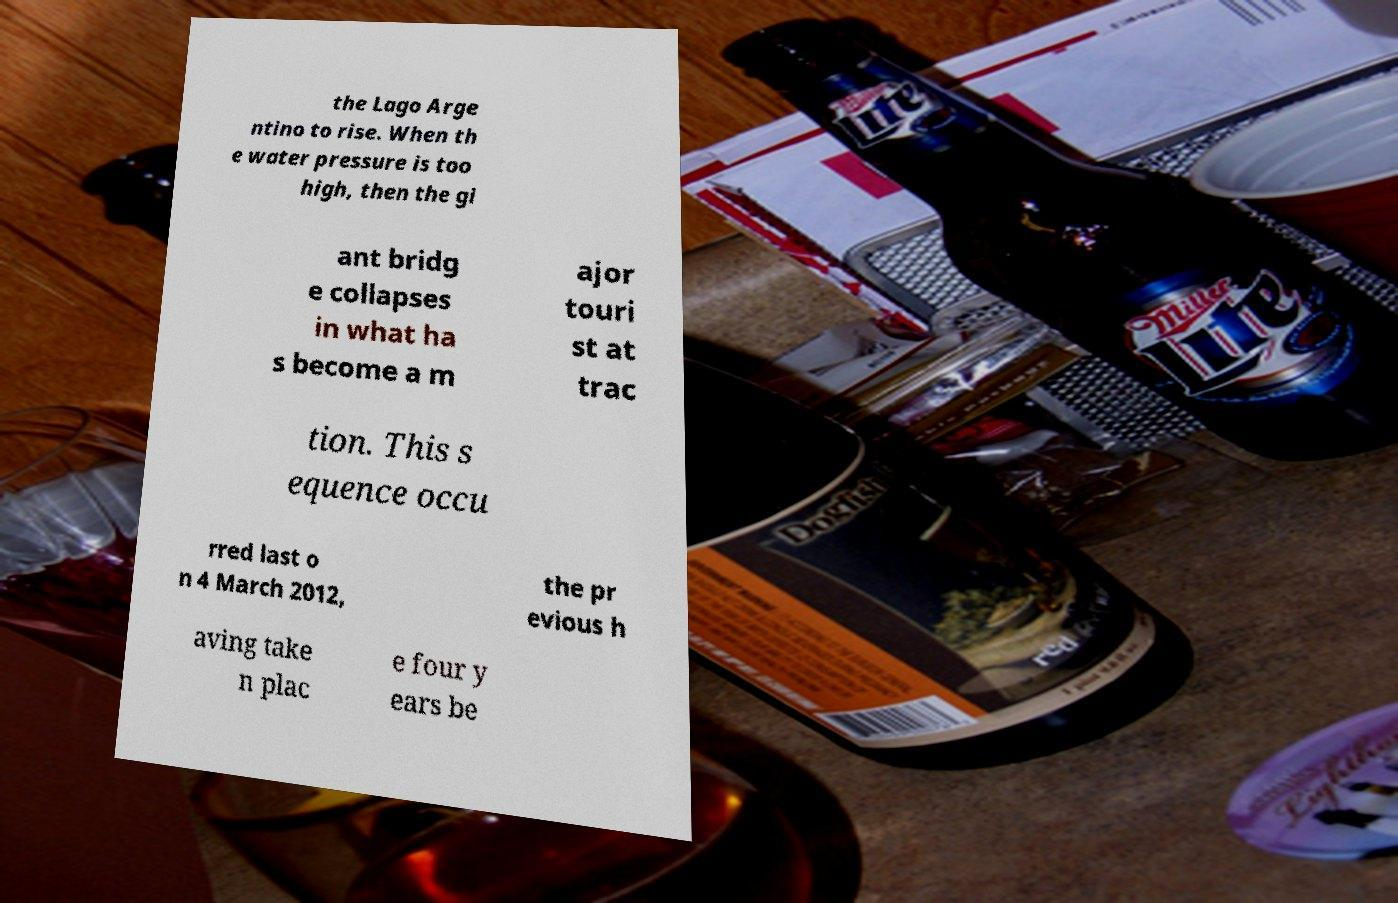Can you read and provide the text displayed in the image?This photo seems to have some interesting text. Can you extract and type it out for me? the Lago Arge ntino to rise. When th e water pressure is too high, then the gi ant bridg e collapses in what ha s become a m ajor touri st at trac tion. This s equence occu rred last o n 4 March 2012, the pr evious h aving take n plac e four y ears be 